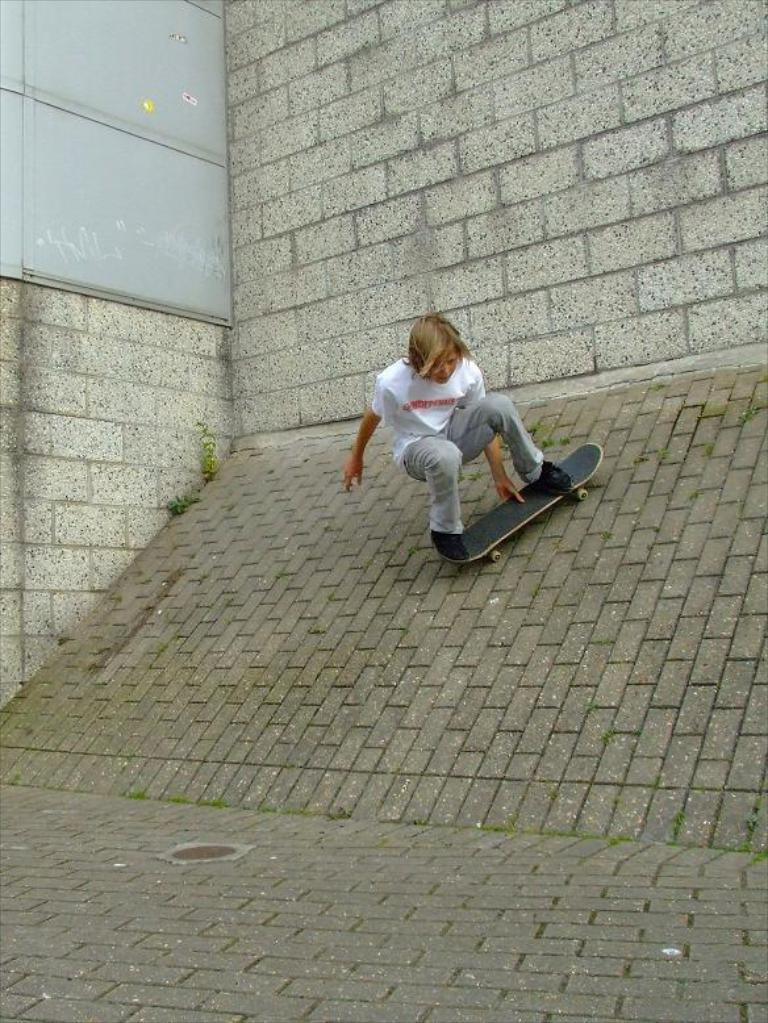What is the person in the image doing? The person in the image is skating. Where is the person in the image located? The person is in the center of the image. What type of surface is visible at the bottom of the image? There is pavement at the bottom of the image. What feature can be seen in the center of the image? There is a slope in the center of the image. What can be seen in the background of the image? There is a building in the background of the image. How many girls are holding a quarter in the image? There are no girls or quarters present in the image. 